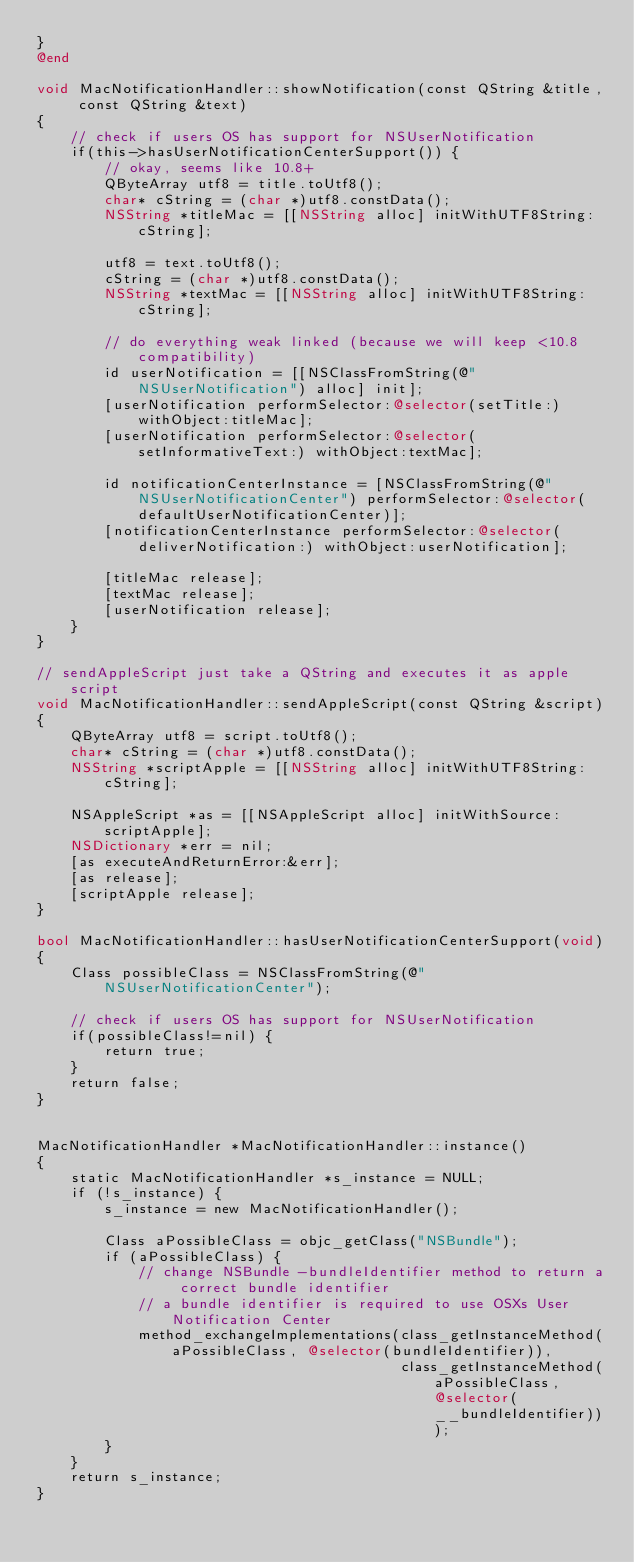<code> <loc_0><loc_0><loc_500><loc_500><_ObjectiveC_>}
@end

void MacNotificationHandler::showNotification(const QString &title, const QString &text)
{
    // check if users OS has support for NSUserNotification
    if(this->hasUserNotificationCenterSupport()) {
        // okay, seems like 10.8+
        QByteArray utf8 = title.toUtf8();
        char* cString = (char *)utf8.constData();
        NSString *titleMac = [[NSString alloc] initWithUTF8String:cString];

        utf8 = text.toUtf8();
        cString = (char *)utf8.constData();
        NSString *textMac = [[NSString alloc] initWithUTF8String:cString];

        // do everything weak linked (because we will keep <10.8 compatibility)
        id userNotification = [[NSClassFromString(@"NSUserNotification") alloc] init];
        [userNotification performSelector:@selector(setTitle:) withObject:titleMac];
        [userNotification performSelector:@selector(setInformativeText:) withObject:textMac];

        id notificationCenterInstance = [NSClassFromString(@"NSUserNotificationCenter") performSelector:@selector(defaultUserNotificationCenter)];
        [notificationCenterInstance performSelector:@selector(deliverNotification:) withObject:userNotification];

        [titleMac release];
        [textMac release];
        [userNotification release];
    }
}

// sendAppleScript just take a QString and executes it as apple script
void MacNotificationHandler::sendAppleScript(const QString &script)
{
    QByteArray utf8 = script.toUtf8();
    char* cString = (char *)utf8.constData();
    NSString *scriptApple = [[NSString alloc] initWithUTF8String:cString];

    NSAppleScript *as = [[NSAppleScript alloc] initWithSource:scriptApple];
    NSDictionary *err = nil;
    [as executeAndReturnError:&err];
    [as release];
    [scriptApple release];
}

bool MacNotificationHandler::hasUserNotificationCenterSupport(void)
{
    Class possibleClass = NSClassFromString(@"NSUserNotificationCenter");

    // check if users OS has support for NSUserNotification
    if(possibleClass!=nil) {
        return true;
    }
    return false;
}


MacNotificationHandler *MacNotificationHandler::instance()
{
    static MacNotificationHandler *s_instance = NULL;
    if (!s_instance) {
        s_instance = new MacNotificationHandler();
        
        Class aPossibleClass = objc_getClass("NSBundle");
        if (aPossibleClass) {
            // change NSBundle -bundleIdentifier method to return a correct bundle identifier
            // a bundle identifier is required to use OSXs User Notification Center
            method_exchangeImplementations(class_getInstanceMethod(aPossibleClass, @selector(bundleIdentifier)),
                                           class_getInstanceMethod(aPossibleClass, @selector(__bundleIdentifier)));
        }
    }
    return s_instance;
}
</code> 